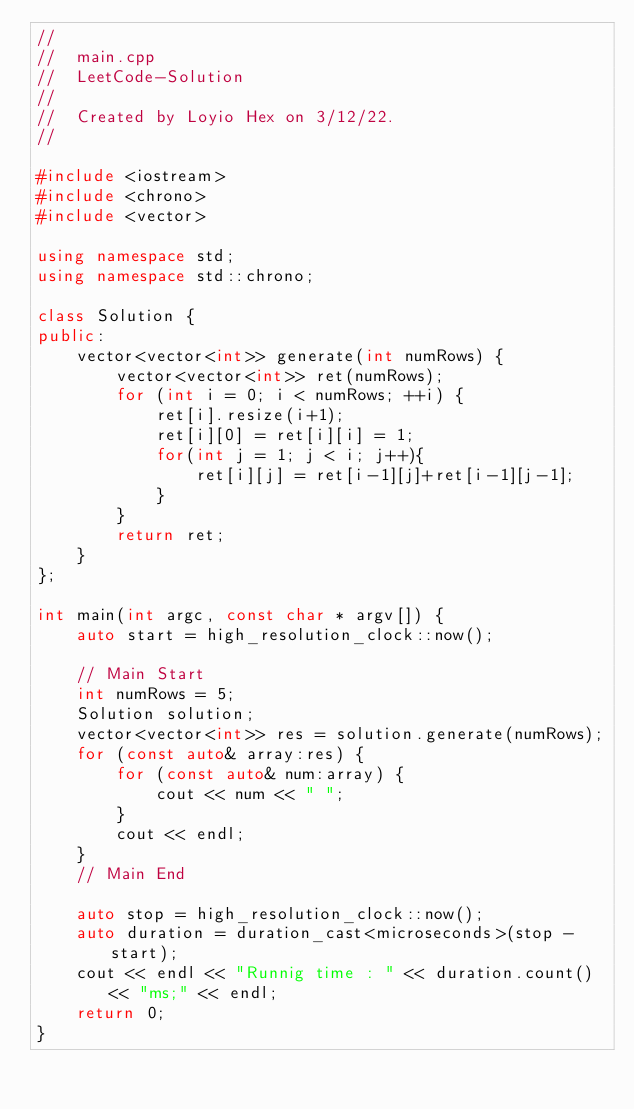Convert code to text. <code><loc_0><loc_0><loc_500><loc_500><_C++_>//
//  main.cpp
//  LeetCode-Solution
//
//  Created by Loyio Hex on 3/12/22.
//

#include <iostream>
#include <chrono>
#include <vector>

using namespace std;
using namespace std::chrono;

class Solution {
public:
    vector<vector<int>> generate(int numRows) {
        vector<vector<int>> ret(numRows);
        for (int i = 0; i < numRows; ++i) {
            ret[i].resize(i+1);
            ret[i][0] = ret[i][i] = 1;
            for(int j = 1; j < i; j++){
                ret[i][j] = ret[i-1][j]+ret[i-1][j-1];
            }
        }
        return ret;
    }
};

int main(int argc, const char * argv[]) {
    auto start = high_resolution_clock::now();

    // Main Start
    int numRows = 5;
    Solution solution;
    vector<vector<int>> res = solution.generate(numRows);
    for (const auto& array:res) {
        for (const auto& num:array) {
            cout << num << " ";
        }
        cout << endl;
    }
    // Main End

    auto stop = high_resolution_clock::now();
    auto duration = duration_cast<microseconds>(stop - start);
    cout << endl << "Runnig time : " << duration.count() << "ms;" << endl;
    return 0;
}


</code> 